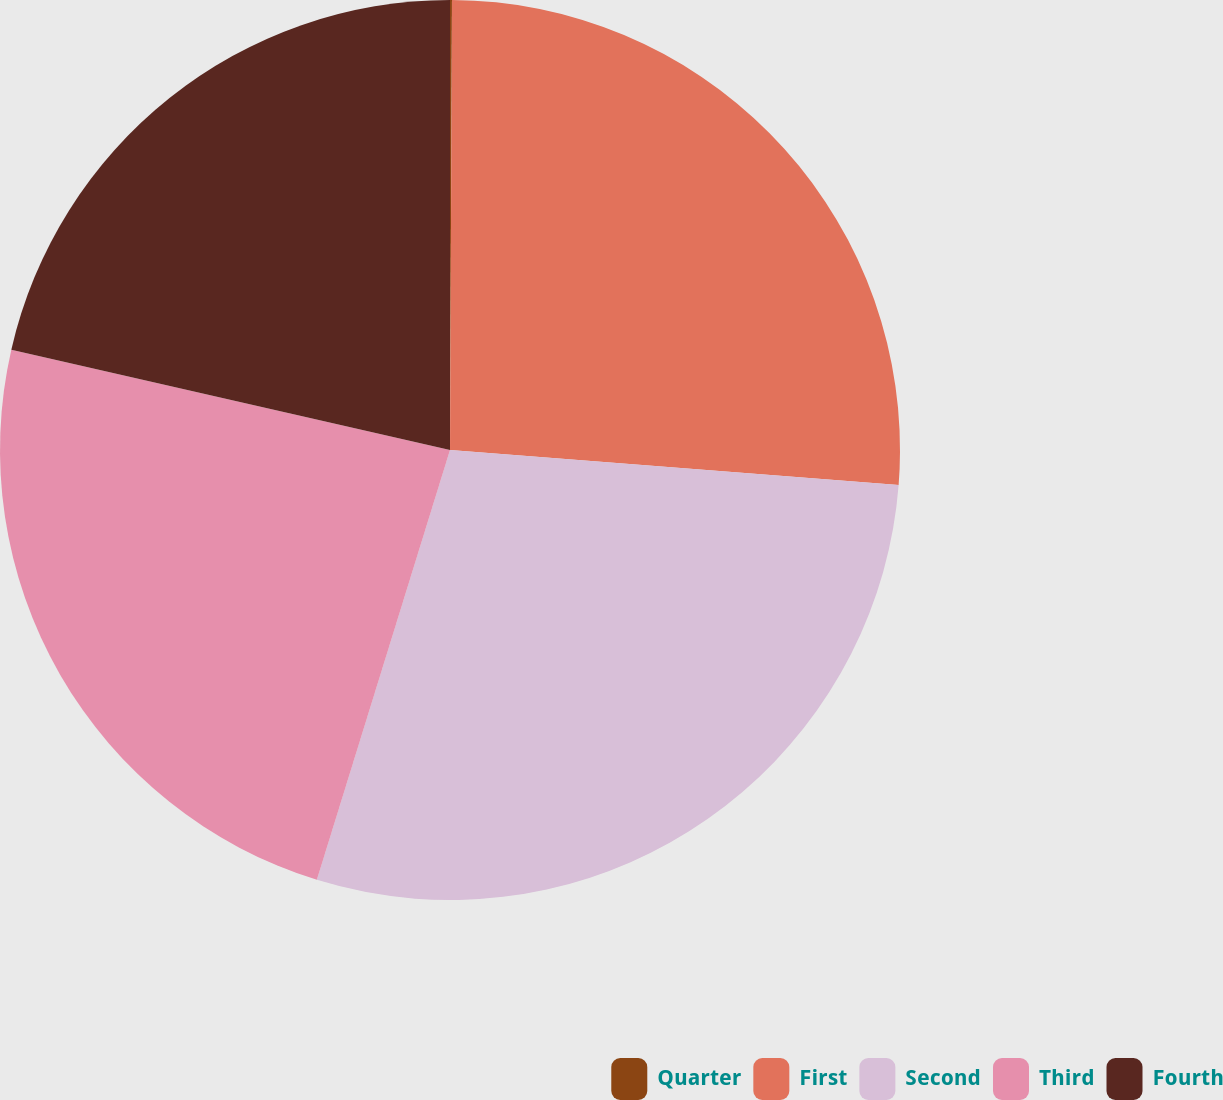<chart> <loc_0><loc_0><loc_500><loc_500><pie_chart><fcel>Quarter<fcel>First<fcel>Second<fcel>Third<fcel>Fourth<nl><fcel>0.07%<fcel>26.17%<fcel>28.54%<fcel>23.8%<fcel>21.42%<nl></chart> 